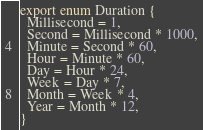<code> <loc_0><loc_0><loc_500><loc_500><_TypeScript_>export enum Duration {
  Millisecond = 1,
  Second = Millisecond * 1000,
  Minute = Second * 60,
  Hour = Minute * 60,
  Day = Hour * 24,
  Week = Day * 7,
  Month = Week * 4,
  Year = Month * 12,
}
</code> 